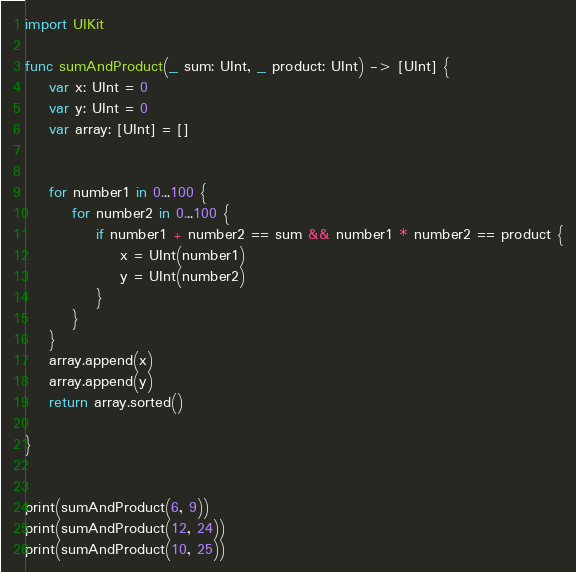<code> <loc_0><loc_0><loc_500><loc_500><_Swift_>import UIKit

func sumAndProduct(_ sum: UInt, _ product: UInt) -> [UInt] {
    var x: UInt = 0
    var y: UInt = 0
    var array: [UInt] = []
    
    
    for number1 in 0...100 {
        for number2 in 0...100 {
            if number1 + number2 == sum && number1 * number2 == product {
                x = UInt(number1)
                y = UInt(number2)
            }
        }
    }
    array.append(x)
    array.append(y)
    return array.sorted()
    
}


print(sumAndProduct(6, 9))
print(sumAndProduct(12, 24))
print(sumAndProduct(10, 25))
</code> 